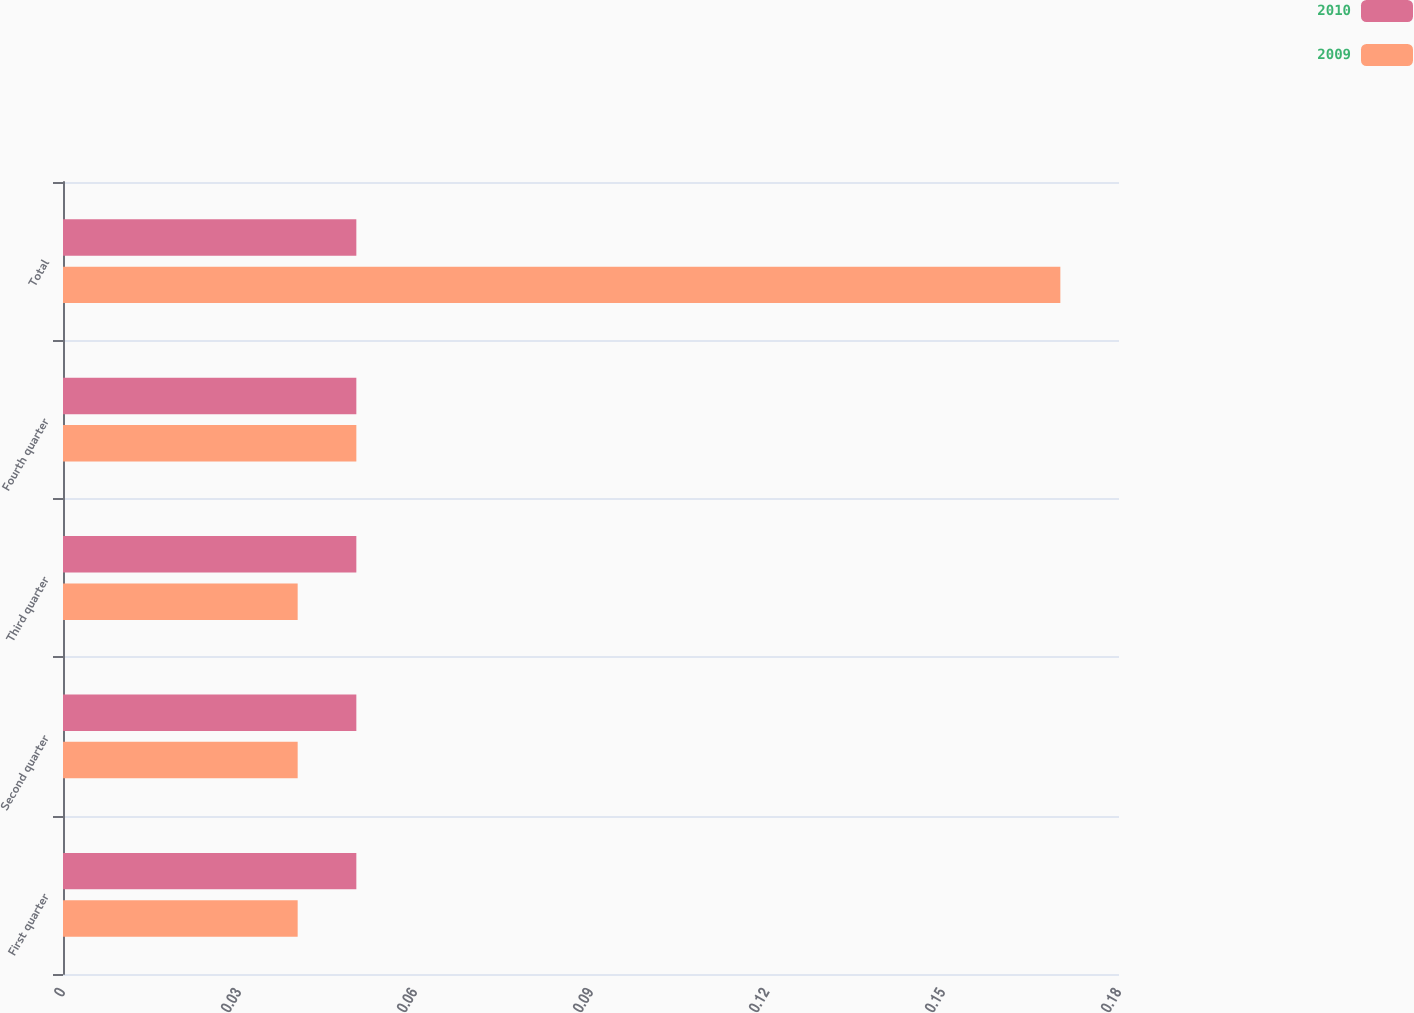<chart> <loc_0><loc_0><loc_500><loc_500><stacked_bar_chart><ecel><fcel>First quarter<fcel>Second quarter<fcel>Third quarter<fcel>Fourth quarter<fcel>Total<nl><fcel>2010<fcel>0.05<fcel>0.05<fcel>0.05<fcel>0.05<fcel>0.05<nl><fcel>2009<fcel>0.04<fcel>0.04<fcel>0.04<fcel>0.05<fcel>0.17<nl></chart> 